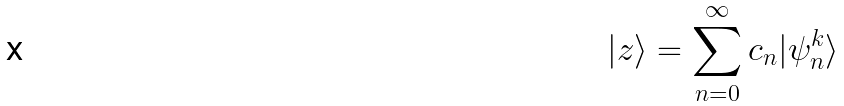<formula> <loc_0><loc_0><loc_500><loc_500>| z \rangle = \sum _ { n = 0 } ^ { \infty } c _ { n } | \psi _ { n } ^ { k } \rangle</formula> 